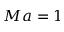<formula> <loc_0><loc_0><loc_500><loc_500>M a = 1</formula> 